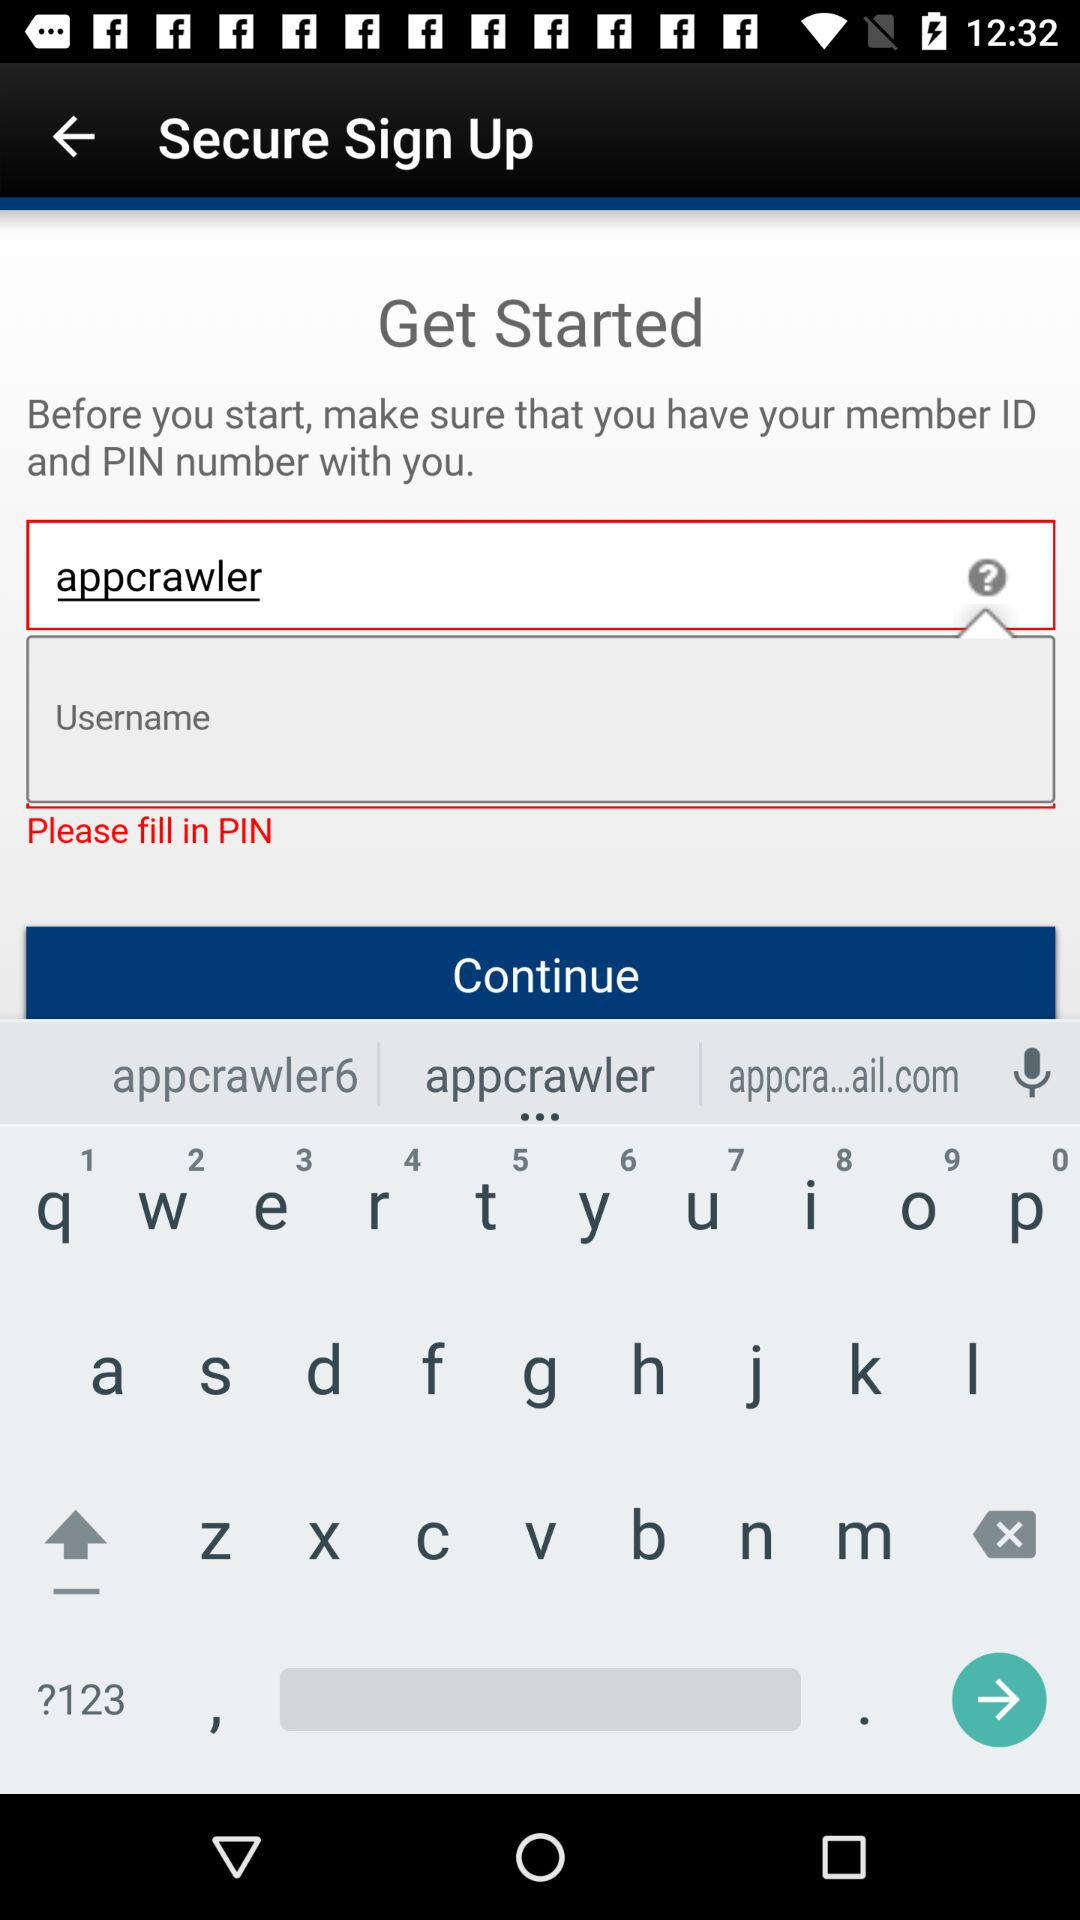What is the username? The username is "appcrawler". 